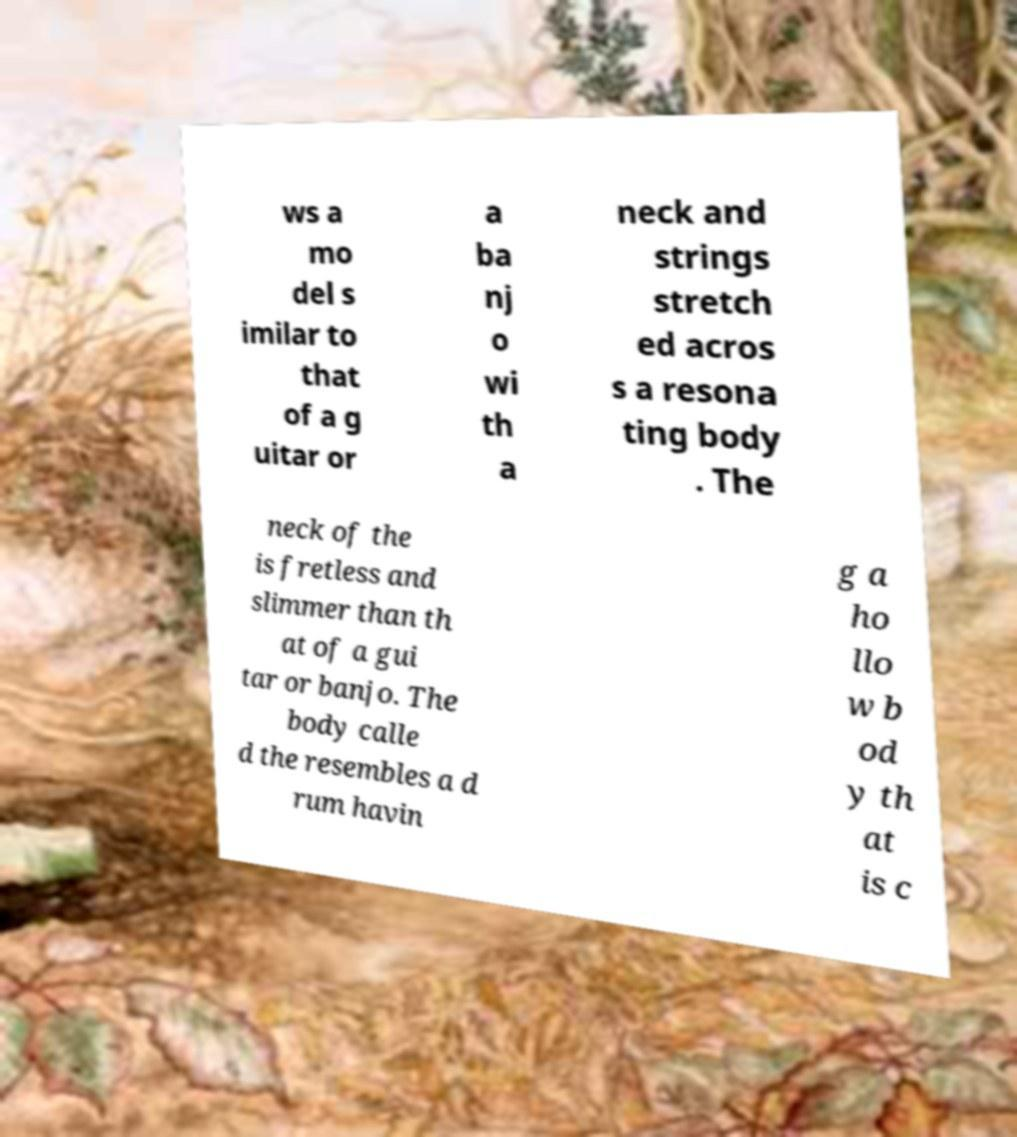For documentation purposes, I need the text within this image transcribed. Could you provide that? ws a mo del s imilar to that of a g uitar or a ba nj o wi th a neck and strings stretch ed acros s a resona ting body . The neck of the is fretless and slimmer than th at of a gui tar or banjo. The body calle d the resembles a d rum havin g a ho llo w b od y th at is c 